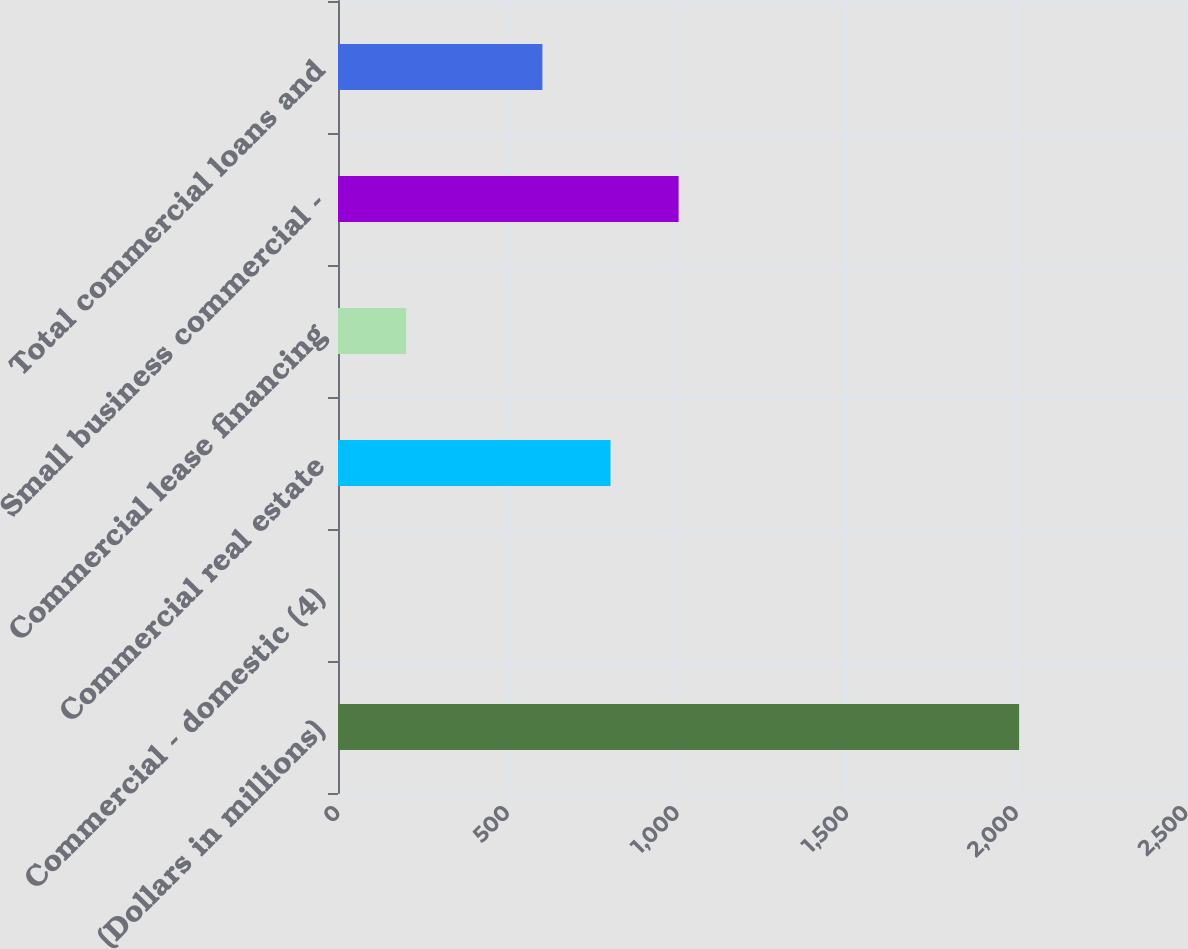<chart> <loc_0><loc_0><loc_500><loc_500><bar_chart><fcel>(Dollars in millions)<fcel>Commercial - domestic (4)<fcel>Commercial real estate<fcel>Commercial lease financing<fcel>Small business commercial -<fcel>Total commercial loans and<nl><fcel>2008<fcel>0.26<fcel>803.34<fcel>201.03<fcel>1004.11<fcel>602.57<nl></chart> 